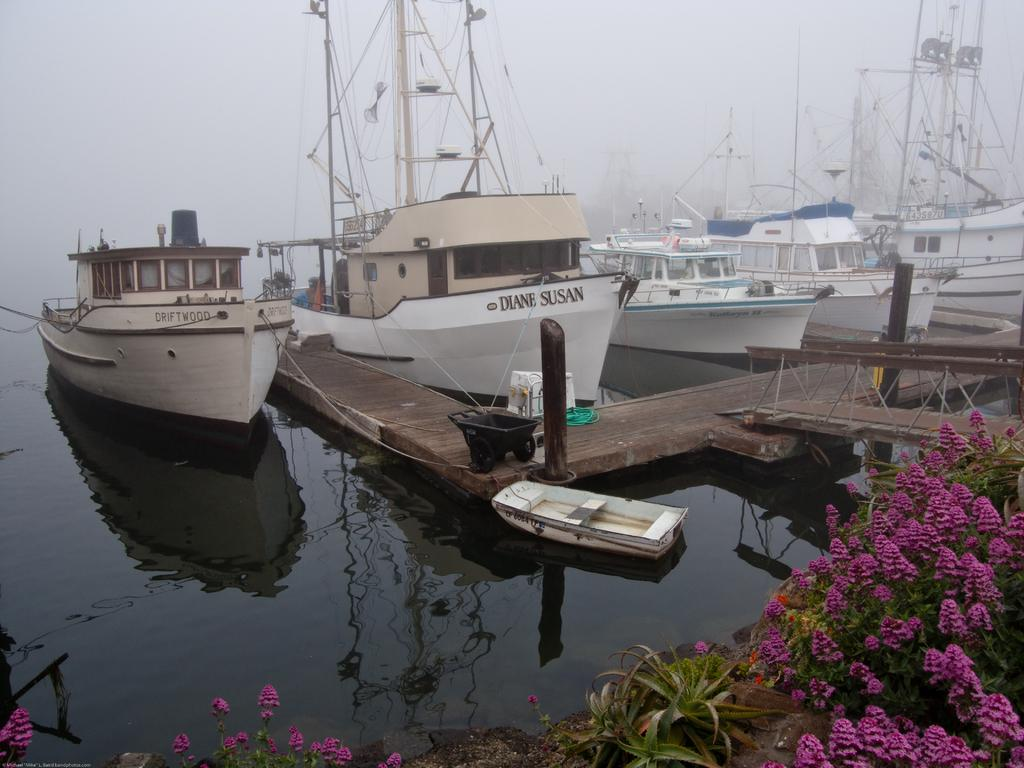What is the main feature of the image? The main feature of the image is water. What is on the water in the image? There are boats on the water in the image. What type of structure is present in the image? There is a board bridge in the image. What type of vegetation can be seen at the bottom of the image? There are plants at the bottom of the image. What type of flora is visible in the image? Flowers are visible in the image. What is visible in the background of the image? The sky is visible in the background of the image. What is the value of the wing in the image? There is no wing present in the image, so it is not possible to determine its value. 